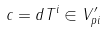<formula> <loc_0><loc_0><loc_500><loc_500>c = d T ^ { i } \in V ^ { \prime } _ { p i }</formula> 